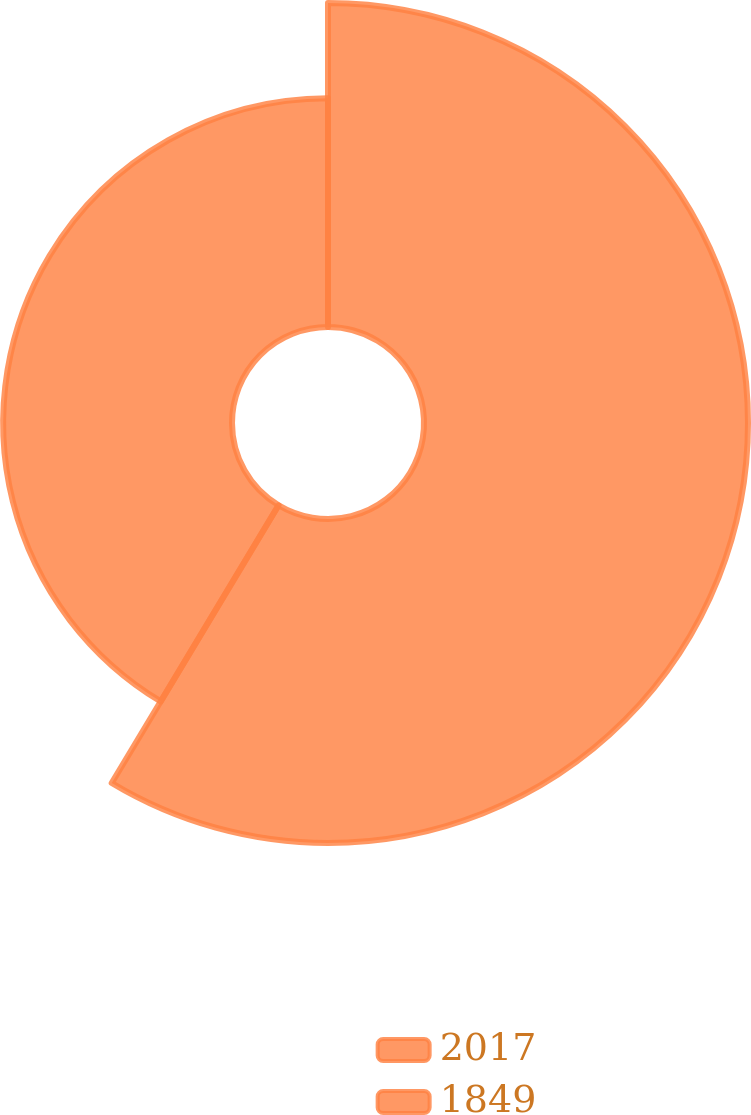Convert chart. <chart><loc_0><loc_0><loc_500><loc_500><pie_chart><fcel>2017<fcel>1849<nl><fcel>58.61%<fcel>41.39%<nl></chart> 